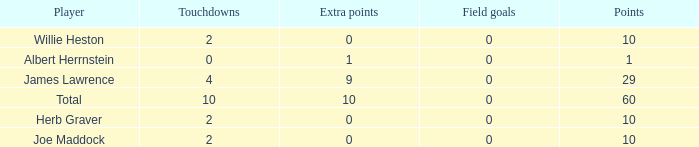What is the highest number of points for players with less than 2 touchdowns and 0 extra points? None. 